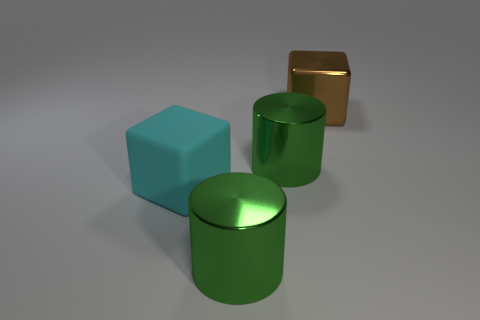What number of large brown objects are there?
Your response must be concise. 1. Are there fewer brown metallic things that are right of the brown shiny cube than large gray balls?
Ensure brevity in your answer.  No. Do the large green cylinder that is in front of the big cyan cube and the big cyan object have the same material?
Make the answer very short. No. There is a large green thing behind the object in front of the cube that is on the left side of the brown shiny object; what shape is it?
Provide a short and direct response. Cylinder. Are there any matte things that have the same size as the brown metal thing?
Your answer should be very brief. Yes. How many blue metal things have the same size as the cyan block?
Ensure brevity in your answer.  0. Are there fewer green shiny things on the right side of the brown thing than brown things that are behind the large matte object?
Make the answer very short. Yes. There is a metallic cylinder on the right side of the metal cylinder in front of the big cube that is in front of the large brown block; what is its size?
Provide a short and direct response. Large. What is the shape of the green object that is in front of the big green metal object that is behind the rubber cube?
Give a very brief answer. Cylinder. Are there any other things that are the same color as the large matte object?
Provide a short and direct response. No. 